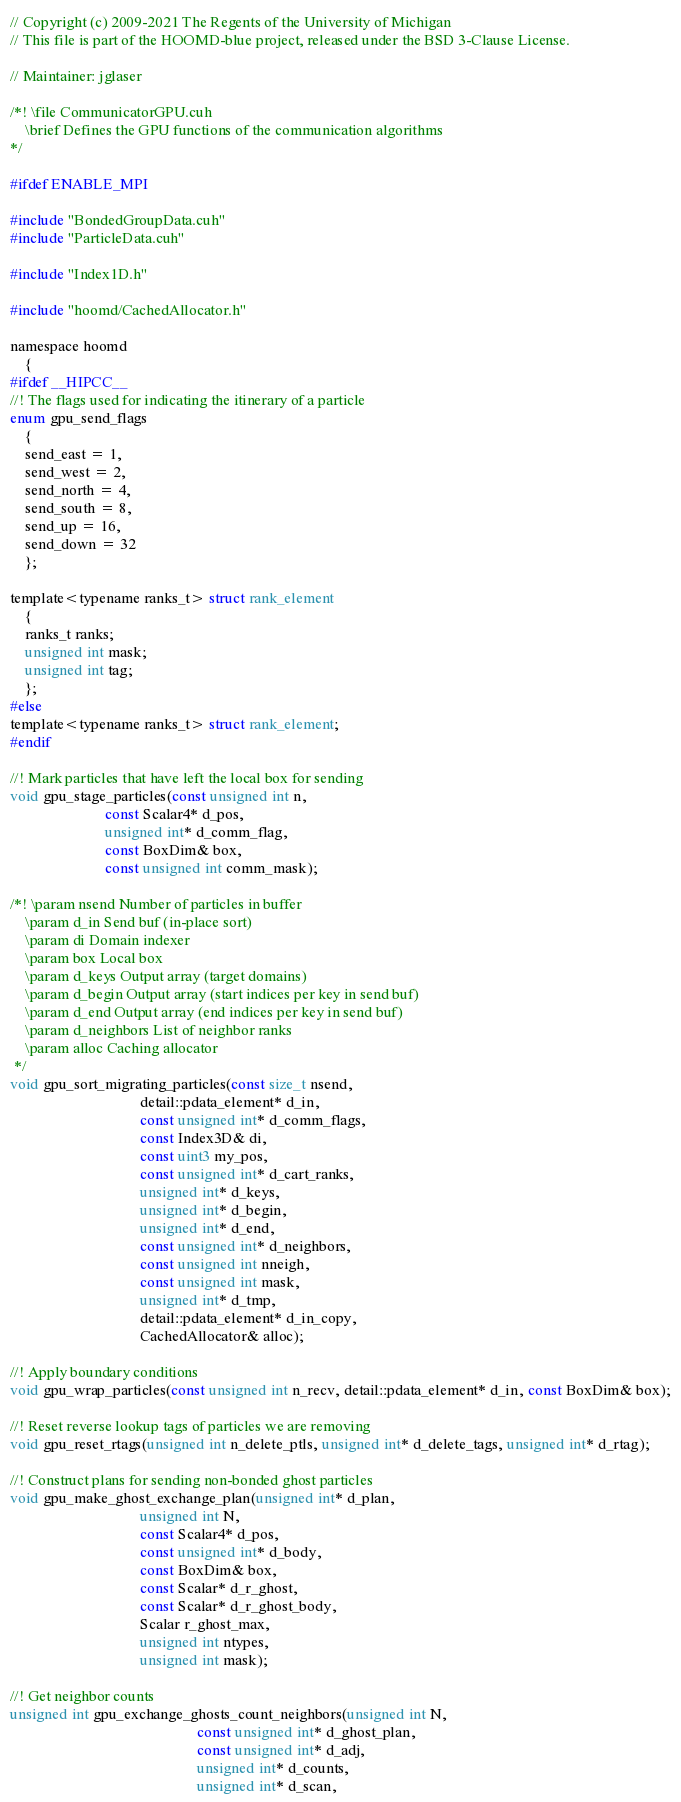<code> <loc_0><loc_0><loc_500><loc_500><_Cuda_>// Copyright (c) 2009-2021 The Regents of the University of Michigan
// This file is part of the HOOMD-blue project, released under the BSD 3-Clause License.

// Maintainer: jglaser

/*! \file CommunicatorGPU.cuh
    \brief Defines the GPU functions of the communication algorithms
*/

#ifdef ENABLE_MPI

#include "BondedGroupData.cuh"
#include "ParticleData.cuh"

#include "Index1D.h"

#include "hoomd/CachedAllocator.h"

namespace hoomd
    {
#ifdef __HIPCC__
//! The flags used for indicating the itinerary of a particle
enum gpu_send_flags
    {
    send_east = 1,
    send_west = 2,
    send_north = 4,
    send_south = 8,
    send_up = 16,
    send_down = 32
    };

template<typename ranks_t> struct rank_element
    {
    ranks_t ranks;
    unsigned int mask;
    unsigned int tag;
    };
#else
template<typename ranks_t> struct rank_element;
#endif

//! Mark particles that have left the local box for sending
void gpu_stage_particles(const unsigned int n,
                         const Scalar4* d_pos,
                         unsigned int* d_comm_flag,
                         const BoxDim& box,
                         const unsigned int comm_mask);

/*! \param nsend Number of particles in buffer
    \param d_in Send buf (in-place sort)
    \param di Domain indexer
    \param box Local box
    \param d_keys Output array (target domains)
    \param d_begin Output array (start indices per key in send buf)
    \param d_end Output array (end indices per key in send buf)
    \param d_neighbors List of neighbor ranks
    \param alloc Caching allocator
 */
void gpu_sort_migrating_particles(const size_t nsend,
                                  detail::pdata_element* d_in,
                                  const unsigned int* d_comm_flags,
                                  const Index3D& di,
                                  const uint3 my_pos,
                                  const unsigned int* d_cart_ranks,
                                  unsigned int* d_keys,
                                  unsigned int* d_begin,
                                  unsigned int* d_end,
                                  const unsigned int* d_neighbors,
                                  const unsigned int nneigh,
                                  const unsigned int mask,
                                  unsigned int* d_tmp,
                                  detail::pdata_element* d_in_copy,
                                  CachedAllocator& alloc);

//! Apply boundary conditions
void gpu_wrap_particles(const unsigned int n_recv, detail::pdata_element* d_in, const BoxDim& box);

//! Reset reverse lookup tags of particles we are removing
void gpu_reset_rtags(unsigned int n_delete_ptls, unsigned int* d_delete_tags, unsigned int* d_rtag);

//! Construct plans for sending non-bonded ghost particles
void gpu_make_ghost_exchange_plan(unsigned int* d_plan,
                                  unsigned int N,
                                  const Scalar4* d_pos,
                                  const unsigned int* d_body,
                                  const BoxDim& box,
                                  const Scalar* d_r_ghost,
                                  const Scalar* d_r_ghost_body,
                                  Scalar r_ghost_max,
                                  unsigned int ntypes,
                                  unsigned int mask);

//! Get neighbor counts
unsigned int gpu_exchange_ghosts_count_neighbors(unsigned int N,
                                                 const unsigned int* d_ghost_plan,
                                                 const unsigned int* d_adj,
                                                 unsigned int* d_counts,
                                                 unsigned int* d_scan,</code> 